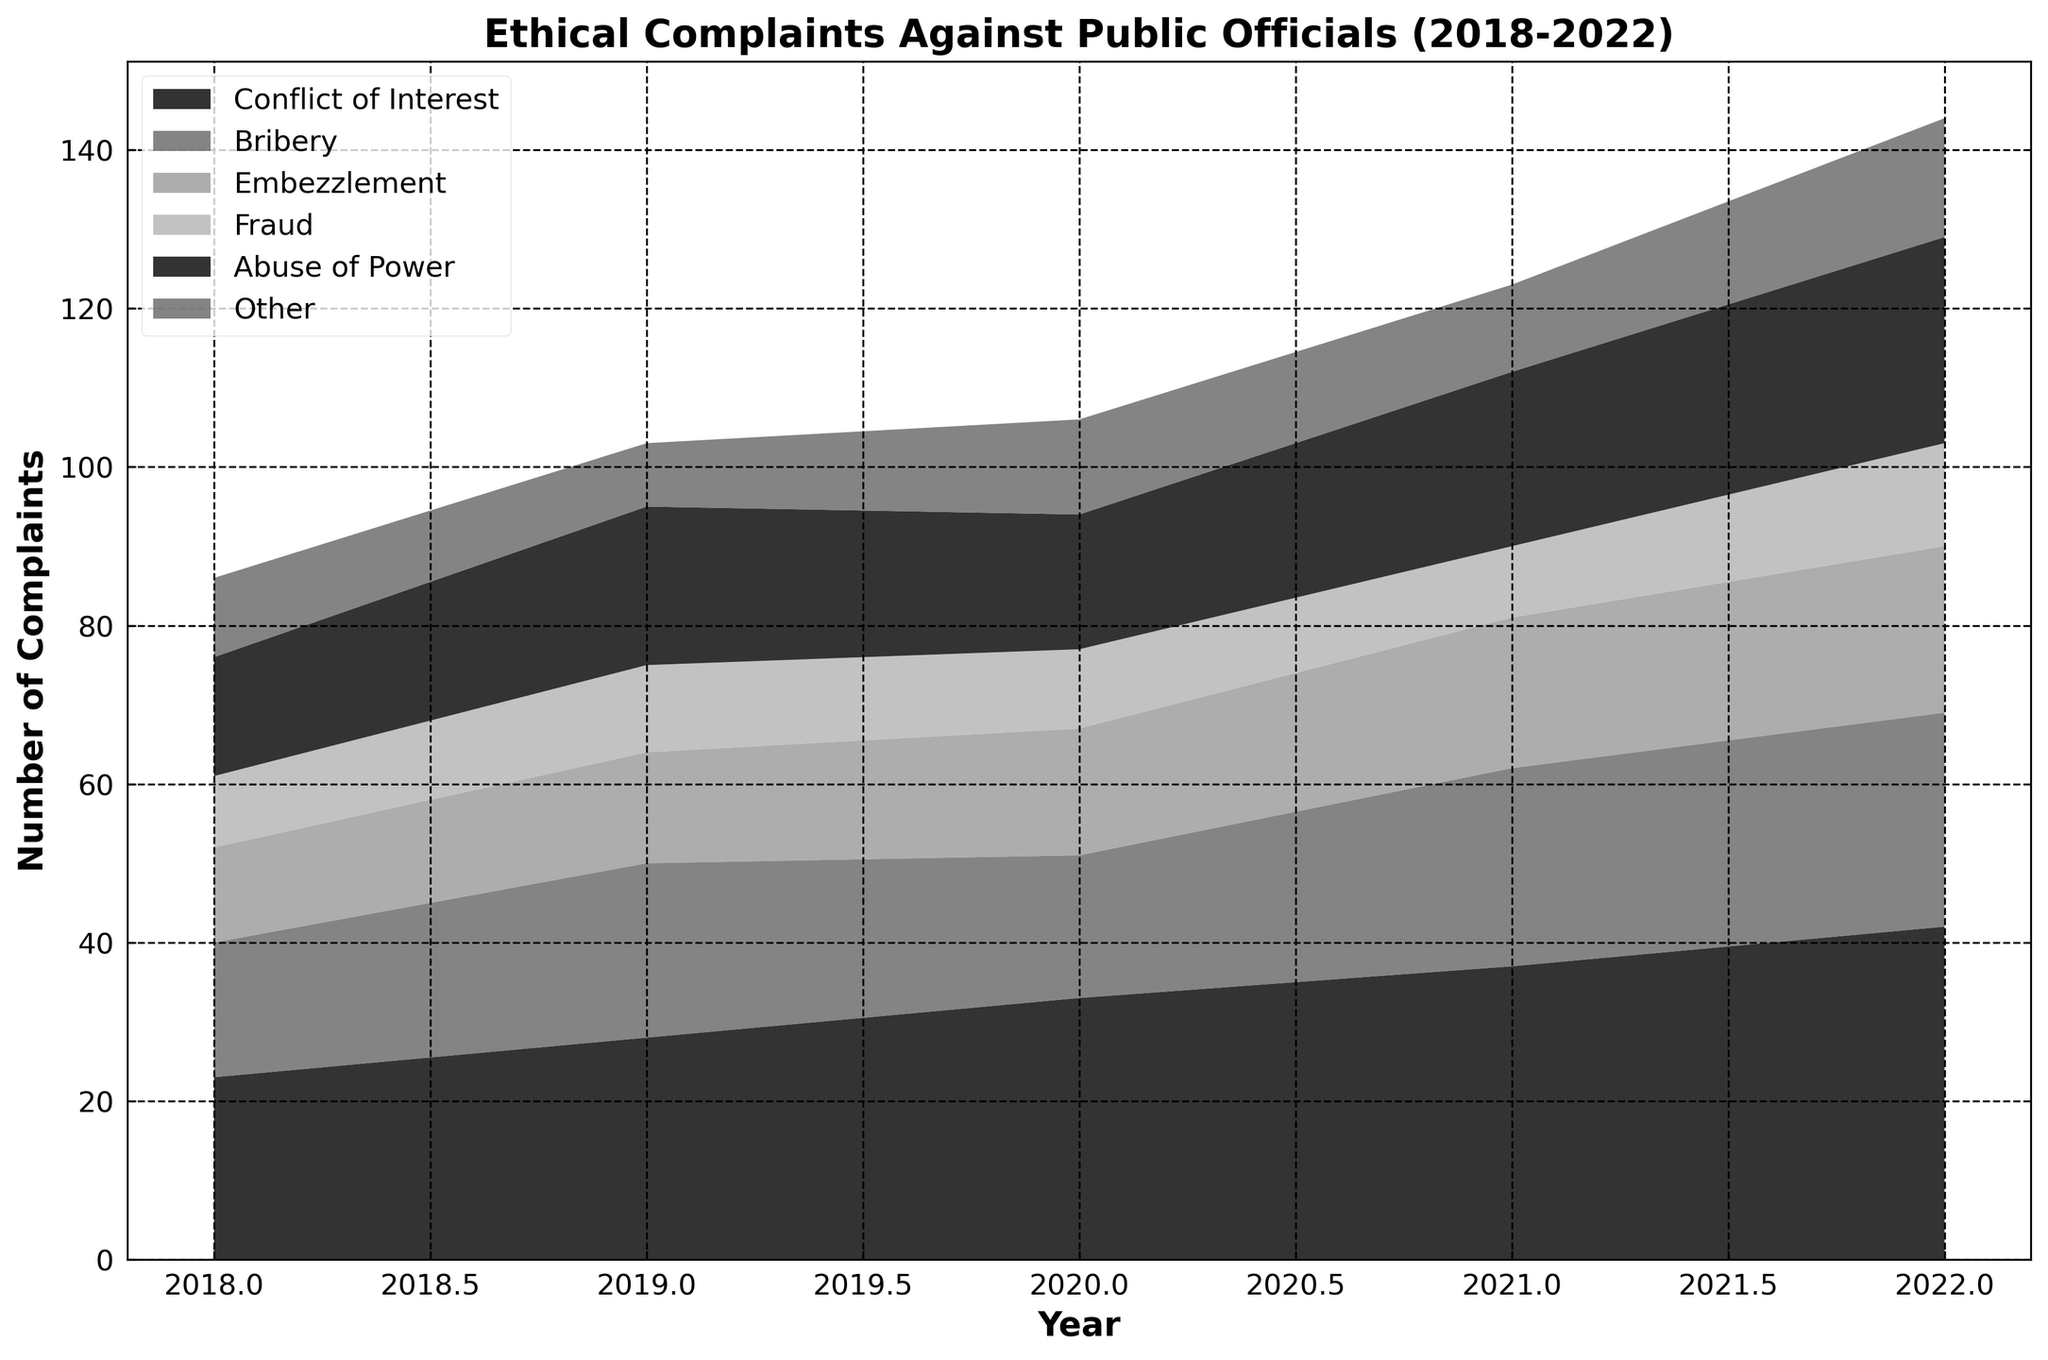Which type of violation had the highest number of complaints in 2022? Look at the highest point for the year 2022; the "Conflict of Interest" area reaches the highest value compared to other violations.
Answer: Conflict of Interest How did the number of "Bribery" complaints change from 2018 to 2022? Observe the height of the "Bribery" section in 2018 and 2022. Count the increase in height across these years. In 2018, there were 17 complaints, increasing to 27 in 2022, an increase of 10 complaints.
Answer: Increased by 10 What is the combined number of "Fraud" and "Abuse of Power" complaints in 2021? Find the height of "Fraud" and "Abuse of Power" in 2021, which are 9 and 22 respectively, and sum these values.
Answer: 31 Which year saw the largest number of total complaints against public officials? Review the total height for each year to see which one has the maximum cumulative value. 2022 has the tallest combined stack.
Answer: 2022 What is the average number of "Embezzlement" complaints over the 5-year period? Total the number of "Embezzlement" complaints over the years (12+14+16+19+21 = 82) and divide by the number of years (82/5 = 16.4).
Answer: 16.4 In which year did "Conflict of Interest" complaints see their largest year-over-year increase? Calculate the year-over-year differences for "Conflict of Interest": from 2018 to 2019 (28-23=5), from 2019 to 2020 (33-28=5), from 2020 to 2021 (37-33=4), from 2021 to 2022 (42-37=5). The largest is in years 2019 and 2020, and 2022, with an increase of 5.
Answer: 2019, 2020, and 2022 Which violation had the smallest increase in complaints from 2018 to 2022? Calculate the difference for each violation from 2018 to 2022: Conflict of Interest (42-23=19), Bribery (27-17=10), Embezzlement (21-12=9), Fraud (13-9=4), Abuse of Power (26-15=11), Other (15-10=5). The smallest increase is for "Fraud".
Answer: Fraud How many more "Abuse of Power" complaints were there in 2022 compared to 2021? Subtract the number of "Abuse of Power" complaints in 2021 from those in 2022 (26-22=4).
Answer: 4 Which violation type shows the least variance in the given period? Examine each type and see the fluctuations over the 5 years. "Other" has relatively consistent numbers from 10 in 2018 to 15 in 2022, indicating the least variance compared to others.
Answer: Other How does the trend of "Fraud" complaints change over the last five years? Observe the "Fraud" section's height from year to year. It shows slight fluctuations but remains within a close range (9, 11, 10, 9, 13), can be described as relatively stable.
Answer: Relatively stable 